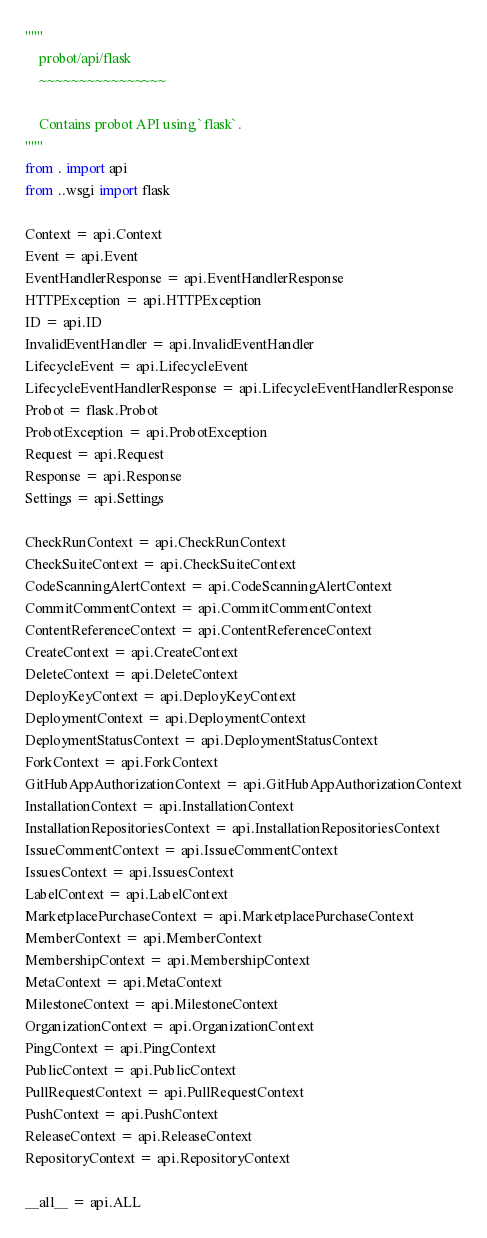Convert code to text. <code><loc_0><loc_0><loc_500><loc_500><_Python_>"""
    probot/api/flask
    ~~~~~~~~~~~~~~~~

    Contains probot API using `flask`.
"""
from . import api
from ..wsgi import flask

Context = api.Context
Event = api.Event
EventHandlerResponse = api.EventHandlerResponse
HTTPException = api.HTTPException
ID = api.ID
InvalidEventHandler = api.InvalidEventHandler
LifecycleEvent = api.LifecycleEvent
LifecycleEventHandlerResponse = api.LifecycleEventHandlerResponse
Probot = flask.Probot
ProbotException = api.ProbotException
Request = api.Request
Response = api.Response
Settings = api.Settings

CheckRunContext = api.CheckRunContext
CheckSuiteContext = api.CheckSuiteContext
CodeScanningAlertContext = api.CodeScanningAlertContext
CommitCommentContext = api.CommitCommentContext
ContentReferenceContext = api.ContentReferenceContext
CreateContext = api.CreateContext
DeleteContext = api.DeleteContext
DeployKeyContext = api.DeployKeyContext
DeploymentContext = api.DeploymentContext
DeploymentStatusContext = api.DeploymentStatusContext
ForkContext = api.ForkContext
GitHubAppAuthorizationContext = api.GitHubAppAuthorizationContext
InstallationContext = api.InstallationContext
InstallationRepositoriesContext = api.InstallationRepositoriesContext
IssueCommentContext = api.IssueCommentContext
IssuesContext = api.IssuesContext
LabelContext = api.LabelContext
MarketplacePurchaseContext = api.MarketplacePurchaseContext
MemberContext = api.MemberContext
MembershipContext = api.MembershipContext
MetaContext = api.MetaContext
MilestoneContext = api.MilestoneContext
OrganizationContext = api.OrganizationContext
PingContext = api.PingContext
PublicContext = api.PublicContext
PullRequestContext = api.PullRequestContext
PushContext = api.PushContext
ReleaseContext = api.ReleaseContext
RepositoryContext = api.RepositoryContext

__all__ = api.ALL
</code> 